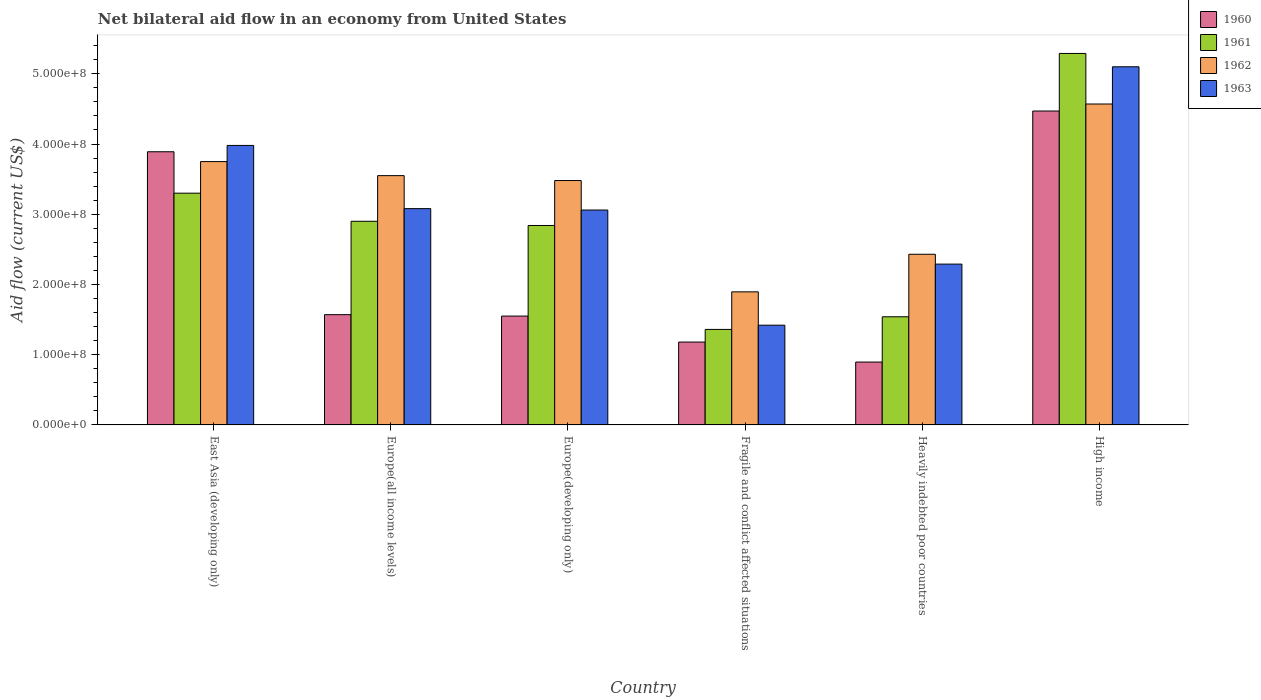How many different coloured bars are there?
Ensure brevity in your answer.  4. Are the number of bars per tick equal to the number of legend labels?
Offer a terse response. Yes. How many bars are there on the 6th tick from the left?
Make the answer very short. 4. What is the label of the 4th group of bars from the left?
Your answer should be very brief. Fragile and conflict affected situations. What is the net bilateral aid flow in 1961 in East Asia (developing only)?
Your answer should be compact. 3.30e+08. Across all countries, what is the maximum net bilateral aid flow in 1963?
Make the answer very short. 5.10e+08. Across all countries, what is the minimum net bilateral aid flow in 1960?
Your answer should be compact. 8.95e+07. In which country was the net bilateral aid flow in 1960 minimum?
Offer a terse response. Heavily indebted poor countries. What is the total net bilateral aid flow in 1962 in the graph?
Give a very brief answer. 1.97e+09. What is the difference between the net bilateral aid flow in 1963 in Europe(developing only) and that in High income?
Offer a very short reply. -2.04e+08. What is the difference between the net bilateral aid flow in 1962 in High income and the net bilateral aid flow in 1963 in Europe(developing only)?
Give a very brief answer. 1.51e+08. What is the average net bilateral aid flow in 1962 per country?
Offer a terse response. 3.28e+08. What is the difference between the net bilateral aid flow of/in 1963 and net bilateral aid flow of/in 1961 in High income?
Your response must be concise. -1.90e+07. What is the ratio of the net bilateral aid flow in 1963 in East Asia (developing only) to that in High income?
Keep it short and to the point. 0.78. Is the net bilateral aid flow in 1963 in Europe(developing only) less than that in Fragile and conflict affected situations?
Offer a terse response. No. What is the difference between the highest and the second highest net bilateral aid flow in 1962?
Give a very brief answer. 1.02e+08. What is the difference between the highest and the lowest net bilateral aid flow in 1963?
Offer a terse response. 3.68e+08. In how many countries, is the net bilateral aid flow in 1960 greater than the average net bilateral aid flow in 1960 taken over all countries?
Ensure brevity in your answer.  2. How many bars are there?
Ensure brevity in your answer.  24. What is the difference between two consecutive major ticks on the Y-axis?
Your answer should be compact. 1.00e+08. Does the graph contain any zero values?
Provide a succinct answer. No. Does the graph contain grids?
Keep it short and to the point. No. Where does the legend appear in the graph?
Your answer should be very brief. Top right. How many legend labels are there?
Give a very brief answer. 4. What is the title of the graph?
Provide a short and direct response. Net bilateral aid flow in an economy from United States. Does "1960" appear as one of the legend labels in the graph?
Keep it short and to the point. Yes. What is the label or title of the X-axis?
Your answer should be very brief. Country. What is the label or title of the Y-axis?
Ensure brevity in your answer.  Aid flow (current US$). What is the Aid flow (current US$) of 1960 in East Asia (developing only)?
Provide a succinct answer. 3.89e+08. What is the Aid flow (current US$) of 1961 in East Asia (developing only)?
Provide a succinct answer. 3.30e+08. What is the Aid flow (current US$) of 1962 in East Asia (developing only)?
Offer a very short reply. 3.75e+08. What is the Aid flow (current US$) of 1963 in East Asia (developing only)?
Ensure brevity in your answer.  3.98e+08. What is the Aid flow (current US$) of 1960 in Europe(all income levels)?
Offer a terse response. 1.57e+08. What is the Aid flow (current US$) of 1961 in Europe(all income levels)?
Make the answer very short. 2.90e+08. What is the Aid flow (current US$) of 1962 in Europe(all income levels)?
Offer a very short reply. 3.55e+08. What is the Aid flow (current US$) in 1963 in Europe(all income levels)?
Ensure brevity in your answer.  3.08e+08. What is the Aid flow (current US$) of 1960 in Europe(developing only)?
Give a very brief answer. 1.55e+08. What is the Aid flow (current US$) in 1961 in Europe(developing only)?
Ensure brevity in your answer.  2.84e+08. What is the Aid flow (current US$) in 1962 in Europe(developing only)?
Offer a terse response. 3.48e+08. What is the Aid flow (current US$) in 1963 in Europe(developing only)?
Provide a succinct answer. 3.06e+08. What is the Aid flow (current US$) in 1960 in Fragile and conflict affected situations?
Keep it short and to the point. 1.18e+08. What is the Aid flow (current US$) in 1961 in Fragile and conflict affected situations?
Ensure brevity in your answer.  1.36e+08. What is the Aid flow (current US$) in 1962 in Fragile and conflict affected situations?
Make the answer very short. 1.90e+08. What is the Aid flow (current US$) of 1963 in Fragile and conflict affected situations?
Give a very brief answer. 1.42e+08. What is the Aid flow (current US$) of 1960 in Heavily indebted poor countries?
Provide a succinct answer. 8.95e+07. What is the Aid flow (current US$) in 1961 in Heavily indebted poor countries?
Keep it short and to the point. 1.54e+08. What is the Aid flow (current US$) of 1962 in Heavily indebted poor countries?
Give a very brief answer. 2.43e+08. What is the Aid flow (current US$) of 1963 in Heavily indebted poor countries?
Keep it short and to the point. 2.29e+08. What is the Aid flow (current US$) in 1960 in High income?
Keep it short and to the point. 4.47e+08. What is the Aid flow (current US$) in 1961 in High income?
Make the answer very short. 5.29e+08. What is the Aid flow (current US$) of 1962 in High income?
Ensure brevity in your answer.  4.57e+08. What is the Aid flow (current US$) of 1963 in High income?
Your response must be concise. 5.10e+08. Across all countries, what is the maximum Aid flow (current US$) of 1960?
Your response must be concise. 4.47e+08. Across all countries, what is the maximum Aid flow (current US$) of 1961?
Make the answer very short. 5.29e+08. Across all countries, what is the maximum Aid flow (current US$) of 1962?
Ensure brevity in your answer.  4.57e+08. Across all countries, what is the maximum Aid flow (current US$) in 1963?
Ensure brevity in your answer.  5.10e+08. Across all countries, what is the minimum Aid flow (current US$) of 1960?
Your answer should be compact. 8.95e+07. Across all countries, what is the minimum Aid flow (current US$) in 1961?
Make the answer very short. 1.36e+08. Across all countries, what is the minimum Aid flow (current US$) in 1962?
Your response must be concise. 1.90e+08. Across all countries, what is the minimum Aid flow (current US$) in 1963?
Make the answer very short. 1.42e+08. What is the total Aid flow (current US$) of 1960 in the graph?
Your answer should be very brief. 1.36e+09. What is the total Aid flow (current US$) of 1961 in the graph?
Offer a very short reply. 1.72e+09. What is the total Aid flow (current US$) of 1962 in the graph?
Provide a succinct answer. 1.97e+09. What is the total Aid flow (current US$) in 1963 in the graph?
Your response must be concise. 1.89e+09. What is the difference between the Aid flow (current US$) of 1960 in East Asia (developing only) and that in Europe(all income levels)?
Offer a very short reply. 2.32e+08. What is the difference between the Aid flow (current US$) of 1961 in East Asia (developing only) and that in Europe(all income levels)?
Keep it short and to the point. 4.00e+07. What is the difference between the Aid flow (current US$) of 1962 in East Asia (developing only) and that in Europe(all income levels)?
Keep it short and to the point. 2.00e+07. What is the difference between the Aid flow (current US$) in 1963 in East Asia (developing only) and that in Europe(all income levels)?
Give a very brief answer. 9.00e+07. What is the difference between the Aid flow (current US$) in 1960 in East Asia (developing only) and that in Europe(developing only)?
Offer a very short reply. 2.34e+08. What is the difference between the Aid flow (current US$) in 1961 in East Asia (developing only) and that in Europe(developing only)?
Make the answer very short. 4.60e+07. What is the difference between the Aid flow (current US$) in 1962 in East Asia (developing only) and that in Europe(developing only)?
Make the answer very short. 2.70e+07. What is the difference between the Aid flow (current US$) of 1963 in East Asia (developing only) and that in Europe(developing only)?
Your response must be concise. 9.20e+07. What is the difference between the Aid flow (current US$) of 1960 in East Asia (developing only) and that in Fragile and conflict affected situations?
Your answer should be compact. 2.71e+08. What is the difference between the Aid flow (current US$) in 1961 in East Asia (developing only) and that in Fragile and conflict affected situations?
Give a very brief answer. 1.94e+08. What is the difference between the Aid flow (current US$) in 1962 in East Asia (developing only) and that in Fragile and conflict affected situations?
Ensure brevity in your answer.  1.86e+08. What is the difference between the Aid flow (current US$) of 1963 in East Asia (developing only) and that in Fragile and conflict affected situations?
Ensure brevity in your answer.  2.56e+08. What is the difference between the Aid flow (current US$) of 1960 in East Asia (developing only) and that in Heavily indebted poor countries?
Give a very brief answer. 2.99e+08. What is the difference between the Aid flow (current US$) of 1961 in East Asia (developing only) and that in Heavily indebted poor countries?
Make the answer very short. 1.76e+08. What is the difference between the Aid flow (current US$) in 1962 in East Asia (developing only) and that in Heavily indebted poor countries?
Your answer should be very brief. 1.32e+08. What is the difference between the Aid flow (current US$) of 1963 in East Asia (developing only) and that in Heavily indebted poor countries?
Provide a succinct answer. 1.69e+08. What is the difference between the Aid flow (current US$) of 1960 in East Asia (developing only) and that in High income?
Provide a succinct answer. -5.80e+07. What is the difference between the Aid flow (current US$) of 1961 in East Asia (developing only) and that in High income?
Provide a succinct answer. -1.99e+08. What is the difference between the Aid flow (current US$) of 1962 in East Asia (developing only) and that in High income?
Keep it short and to the point. -8.20e+07. What is the difference between the Aid flow (current US$) of 1963 in East Asia (developing only) and that in High income?
Keep it short and to the point. -1.12e+08. What is the difference between the Aid flow (current US$) in 1960 in Europe(all income levels) and that in Europe(developing only)?
Your answer should be compact. 2.00e+06. What is the difference between the Aid flow (current US$) in 1962 in Europe(all income levels) and that in Europe(developing only)?
Keep it short and to the point. 7.00e+06. What is the difference between the Aid flow (current US$) in 1960 in Europe(all income levels) and that in Fragile and conflict affected situations?
Ensure brevity in your answer.  3.90e+07. What is the difference between the Aid flow (current US$) in 1961 in Europe(all income levels) and that in Fragile and conflict affected situations?
Your answer should be compact. 1.54e+08. What is the difference between the Aid flow (current US$) of 1962 in Europe(all income levels) and that in Fragile and conflict affected situations?
Offer a terse response. 1.66e+08. What is the difference between the Aid flow (current US$) in 1963 in Europe(all income levels) and that in Fragile and conflict affected situations?
Provide a short and direct response. 1.66e+08. What is the difference between the Aid flow (current US$) of 1960 in Europe(all income levels) and that in Heavily indebted poor countries?
Keep it short and to the point. 6.75e+07. What is the difference between the Aid flow (current US$) in 1961 in Europe(all income levels) and that in Heavily indebted poor countries?
Keep it short and to the point. 1.36e+08. What is the difference between the Aid flow (current US$) of 1962 in Europe(all income levels) and that in Heavily indebted poor countries?
Make the answer very short. 1.12e+08. What is the difference between the Aid flow (current US$) in 1963 in Europe(all income levels) and that in Heavily indebted poor countries?
Your answer should be compact. 7.90e+07. What is the difference between the Aid flow (current US$) of 1960 in Europe(all income levels) and that in High income?
Provide a short and direct response. -2.90e+08. What is the difference between the Aid flow (current US$) in 1961 in Europe(all income levels) and that in High income?
Ensure brevity in your answer.  -2.39e+08. What is the difference between the Aid flow (current US$) in 1962 in Europe(all income levels) and that in High income?
Provide a succinct answer. -1.02e+08. What is the difference between the Aid flow (current US$) of 1963 in Europe(all income levels) and that in High income?
Your answer should be very brief. -2.02e+08. What is the difference between the Aid flow (current US$) in 1960 in Europe(developing only) and that in Fragile and conflict affected situations?
Keep it short and to the point. 3.70e+07. What is the difference between the Aid flow (current US$) of 1961 in Europe(developing only) and that in Fragile and conflict affected situations?
Provide a short and direct response. 1.48e+08. What is the difference between the Aid flow (current US$) of 1962 in Europe(developing only) and that in Fragile and conflict affected situations?
Make the answer very short. 1.58e+08. What is the difference between the Aid flow (current US$) of 1963 in Europe(developing only) and that in Fragile and conflict affected situations?
Your answer should be compact. 1.64e+08. What is the difference between the Aid flow (current US$) of 1960 in Europe(developing only) and that in Heavily indebted poor countries?
Provide a succinct answer. 6.55e+07. What is the difference between the Aid flow (current US$) in 1961 in Europe(developing only) and that in Heavily indebted poor countries?
Provide a short and direct response. 1.30e+08. What is the difference between the Aid flow (current US$) of 1962 in Europe(developing only) and that in Heavily indebted poor countries?
Offer a very short reply. 1.05e+08. What is the difference between the Aid flow (current US$) of 1963 in Europe(developing only) and that in Heavily indebted poor countries?
Provide a succinct answer. 7.70e+07. What is the difference between the Aid flow (current US$) of 1960 in Europe(developing only) and that in High income?
Provide a succinct answer. -2.92e+08. What is the difference between the Aid flow (current US$) in 1961 in Europe(developing only) and that in High income?
Offer a very short reply. -2.45e+08. What is the difference between the Aid flow (current US$) of 1962 in Europe(developing only) and that in High income?
Provide a short and direct response. -1.09e+08. What is the difference between the Aid flow (current US$) of 1963 in Europe(developing only) and that in High income?
Keep it short and to the point. -2.04e+08. What is the difference between the Aid flow (current US$) of 1960 in Fragile and conflict affected situations and that in Heavily indebted poor countries?
Give a very brief answer. 2.85e+07. What is the difference between the Aid flow (current US$) in 1961 in Fragile and conflict affected situations and that in Heavily indebted poor countries?
Your answer should be very brief. -1.80e+07. What is the difference between the Aid flow (current US$) in 1962 in Fragile and conflict affected situations and that in Heavily indebted poor countries?
Keep it short and to the point. -5.35e+07. What is the difference between the Aid flow (current US$) of 1963 in Fragile and conflict affected situations and that in Heavily indebted poor countries?
Provide a succinct answer. -8.70e+07. What is the difference between the Aid flow (current US$) in 1960 in Fragile and conflict affected situations and that in High income?
Keep it short and to the point. -3.29e+08. What is the difference between the Aid flow (current US$) in 1961 in Fragile and conflict affected situations and that in High income?
Ensure brevity in your answer.  -3.93e+08. What is the difference between the Aid flow (current US$) of 1962 in Fragile and conflict affected situations and that in High income?
Give a very brief answer. -2.68e+08. What is the difference between the Aid flow (current US$) in 1963 in Fragile and conflict affected situations and that in High income?
Your answer should be very brief. -3.68e+08. What is the difference between the Aid flow (current US$) of 1960 in Heavily indebted poor countries and that in High income?
Offer a terse response. -3.57e+08. What is the difference between the Aid flow (current US$) of 1961 in Heavily indebted poor countries and that in High income?
Offer a very short reply. -3.75e+08. What is the difference between the Aid flow (current US$) of 1962 in Heavily indebted poor countries and that in High income?
Offer a terse response. -2.14e+08. What is the difference between the Aid flow (current US$) in 1963 in Heavily indebted poor countries and that in High income?
Keep it short and to the point. -2.81e+08. What is the difference between the Aid flow (current US$) in 1960 in East Asia (developing only) and the Aid flow (current US$) in 1961 in Europe(all income levels)?
Offer a terse response. 9.90e+07. What is the difference between the Aid flow (current US$) of 1960 in East Asia (developing only) and the Aid flow (current US$) of 1962 in Europe(all income levels)?
Offer a terse response. 3.40e+07. What is the difference between the Aid flow (current US$) of 1960 in East Asia (developing only) and the Aid flow (current US$) of 1963 in Europe(all income levels)?
Your answer should be compact. 8.10e+07. What is the difference between the Aid flow (current US$) in 1961 in East Asia (developing only) and the Aid flow (current US$) in 1962 in Europe(all income levels)?
Ensure brevity in your answer.  -2.50e+07. What is the difference between the Aid flow (current US$) in 1961 in East Asia (developing only) and the Aid flow (current US$) in 1963 in Europe(all income levels)?
Ensure brevity in your answer.  2.20e+07. What is the difference between the Aid flow (current US$) of 1962 in East Asia (developing only) and the Aid flow (current US$) of 1963 in Europe(all income levels)?
Your answer should be compact. 6.70e+07. What is the difference between the Aid flow (current US$) in 1960 in East Asia (developing only) and the Aid flow (current US$) in 1961 in Europe(developing only)?
Keep it short and to the point. 1.05e+08. What is the difference between the Aid flow (current US$) of 1960 in East Asia (developing only) and the Aid flow (current US$) of 1962 in Europe(developing only)?
Your response must be concise. 4.10e+07. What is the difference between the Aid flow (current US$) in 1960 in East Asia (developing only) and the Aid flow (current US$) in 1963 in Europe(developing only)?
Your answer should be compact. 8.30e+07. What is the difference between the Aid flow (current US$) of 1961 in East Asia (developing only) and the Aid flow (current US$) of 1962 in Europe(developing only)?
Offer a very short reply. -1.80e+07. What is the difference between the Aid flow (current US$) of 1961 in East Asia (developing only) and the Aid flow (current US$) of 1963 in Europe(developing only)?
Make the answer very short. 2.40e+07. What is the difference between the Aid flow (current US$) in 1962 in East Asia (developing only) and the Aid flow (current US$) in 1963 in Europe(developing only)?
Provide a succinct answer. 6.90e+07. What is the difference between the Aid flow (current US$) in 1960 in East Asia (developing only) and the Aid flow (current US$) in 1961 in Fragile and conflict affected situations?
Make the answer very short. 2.53e+08. What is the difference between the Aid flow (current US$) in 1960 in East Asia (developing only) and the Aid flow (current US$) in 1962 in Fragile and conflict affected situations?
Make the answer very short. 2.00e+08. What is the difference between the Aid flow (current US$) in 1960 in East Asia (developing only) and the Aid flow (current US$) in 1963 in Fragile and conflict affected situations?
Ensure brevity in your answer.  2.47e+08. What is the difference between the Aid flow (current US$) in 1961 in East Asia (developing only) and the Aid flow (current US$) in 1962 in Fragile and conflict affected situations?
Your answer should be very brief. 1.40e+08. What is the difference between the Aid flow (current US$) of 1961 in East Asia (developing only) and the Aid flow (current US$) of 1963 in Fragile and conflict affected situations?
Offer a very short reply. 1.88e+08. What is the difference between the Aid flow (current US$) of 1962 in East Asia (developing only) and the Aid flow (current US$) of 1963 in Fragile and conflict affected situations?
Provide a succinct answer. 2.33e+08. What is the difference between the Aid flow (current US$) in 1960 in East Asia (developing only) and the Aid flow (current US$) in 1961 in Heavily indebted poor countries?
Your response must be concise. 2.35e+08. What is the difference between the Aid flow (current US$) of 1960 in East Asia (developing only) and the Aid flow (current US$) of 1962 in Heavily indebted poor countries?
Provide a short and direct response. 1.46e+08. What is the difference between the Aid flow (current US$) in 1960 in East Asia (developing only) and the Aid flow (current US$) in 1963 in Heavily indebted poor countries?
Your answer should be compact. 1.60e+08. What is the difference between the Aid flow (current US$) in 1961 in East Asia (developing only) and the Aid flow (current US$) in 1962 in Heavily indebted poor countries?
Your answer should be very brief. 8.70e+07. What is the difference between the Aid flow (current US$) in 1961 in East Asia (developing only) and the Aid flow (current US$) in 1963 in Heavily indebted poor countries?
Your response must be concise. 1.01e+08. What is the difference between the Aid flow (current US$) in 1962 in East Asia (developing only) and the Aid flow (current US$) in 1963 in Heavily indebted poor countries?
Offer a very short reply. 1.46e+08. What is the difference between the Aid flow (current US$) in 1960 in East Asia (developing only) and the Aid flow (current US$) in 1961 in High income?
Your answer should be compact. -1.40e+08. What is the difference between the Aid flow (current US$) in 1960 in East Asia (developing only) and the Aid flow (current US$) in 1962 in High income?
Ensure brevity in your answer.  -6.80e+07. What is the difference between the Aid flow (current US$) of 1960 in East Asia (developing only) and the Aid flow (current US$) of 1963 in High income?
Your response must be concise. -1.21e+08. What is the difference between the Aid flow (current US$) of 1961 in East Asia (developing only) and the Aid flow (current US$) of 1962 in High income?
Your answer should be very brief. -1.27e+08. What is the difference between the Aid flow (current US$) in 1961 in East Asia (developing only) and the Aid flow (current US$) in 1963 in High income?
Provide a short and direct response. -1.80e+08. What is the difference between the Aid flow (current US$) in 1962 in East Asia (developing only) and the Aid flow (current US$) in 1963 in High income?
Offer a very short reply. -1.35e+08. What is the difference between the Aid flow (current US$) in 1960 in Europe(all income levels) and the Aid flow (current US$) in 1961 in Europe(developing only)?
Provide a succinct answer. -1.27e+08. What is the difference between the Aid flow (current US$) in 1960 in Europe(all income levels) and the Aid flow (current US$) in 1962 in Europe(developing only)?
Provide a succinct answer. -1.91e+08. What is the difference between the Aid flow (current US$) in 1960 in Europe(all income levels) and the Aid flow (current US$) in 1963 in Europe(developing only)?
Offer a terse response. -1.49e+08. What is the difference between the Aid flow (current US$) of 1961 in Europe(all income levels) and the Aid flow (current US$) of 1962 in Europe(developing only)?
Ensure brevity in your answer.  -5.80e+07. What is the difference between the Aid flow (current US$) in 1961 in Europe(all income levels) and the Aid flow (current US$) in 1963 in Europe(developing only)?
Your response must be concise. -1.60e+07. What is the difference between the Aid flow (current US$) in 1962 in Europe(all income levels) and the Aid flow (current US$) in 1963 in Europe(developing only)?
Provide a short and direct response. 4.90e+07. What is the difference between the Aid flow (current US$) of 1960 in Europe(all income levels) and the Aid flow (current US$) of 1961 in Fragile and conflict affected situations?
Offer a very short reply. 2.10e+07. What is the difference between the Aid flow (current US$) of 1960 in Europe(all income levels) and the Aid flow (current US$) of 1962 in Fragile and conflict affected situations?
Your response must be concise. -3.25e+07. What is the difference between the Aid flow (current US$) of 1960 in Europe(all income levels) and the Aid flow (current US$) of 1963 in Fragile and conflict affected situations?
Offer a very short reply. 1.50e+07. What is the difference between the Aid flow (current US$) of 1961 in Europe(all income levels) and the Aid flow (current US$) of 1962 in Fragile and conflict affected situations?
Give a very brief answer. 1.00e+08. What is the difference between the Aid flow (current US$) in 1961 in Europe(all income levels) and the Aid flow (current US$) in 1963 in Fragile and conflict affected situations?
Provide a succinct answer. 1.48e+08. What is the difference between the Aid flow (current US$) of 1962 in Europe(all income levels) and the Aid flow (current US$) of 1963 in Fragile and conflict affected situations?
Ensure brevity in your answer.  2.13e+08. What is the difference between the Aid flow (current US$) of 1960 in Europe(all income levels) and the Aid flow (current US$) of 1961 in Heavily indebted poor countries?
Keep it short and to the point. 3.00e+06. What is the difference between the Aid flow (current US$) in 1960 in Europe(all income levels) and the Aid flow (current US$) in 1962 in Heavily indebted poor countries?
Your answer should be compact. -8.60e+07. What is the difference between the Aid flow (current US$) in 1960 in Europe(all income levels) and the Aid flow (current US$) in 1963 in Heavily indebted poor countries?
Make the answer very short. -7.20e+07. What is the difference between the Aid flow (current US$) of 1961 in Europe(all income levels) and the Aid flow (current US$) of 1962 in Heavily indebted poor countries?
Ensure brevity in your answer.  4.70e+07. What is the difference between the Aid flow (current US$) of 1961 in Europe(all income levels) and the Aid flow (current US$) of 1963 in Heavily indebted poor countries?
Your answer should be compact. 6.10e+07. What is the difference between the Aid flow (current US$) in 1962 in Europe(all income levels) and the Aid flow (current US$) in 1963 in Heavily indebted poor countries?
Offer a terse response. 1.26e+08. What is the difference between the Aid flow (current US$) in 1960 in Europe(all income levels) and the Aid flow (current US$) in 1961 in High income?
Offer a very short reply. -3.72e+08. What is the difference between the Aid flow (current US$) of 1960 in Europe(all income levels) and the Aid flow (current US$) of 1962 in High income?
Your answer should be compact. -3.00e+08. What is the difference between the Aid flow (current US$) in 1960 in Europe(all income levels) and the Aid flow (current US$) in 1963 in High income?
Your response must be concise. -3.53e+08. What is the difference between the Aid flow (current US$) of 1961 in Europe(all income levels) and the Aid flow (current US$) of 1962 in High income?
Provide a short and direct response. -1.67e+08. What is the difference between the Aid flow (current US$) in 1961 in Europe(all income levels) and the Aid flow (current US$) in 1963 in High income?
Provide a short and direct response. -2.20e+08. What is the difference between the Aid flow (current US$) in 1962 in Europe(all income levels) and the Aid flow (current US$) in 1963 in High income?
Your answer should be compact. -1.55e+08. What is the difference between the Aid flow (current US$) of 1960 in Europe(developing only) and the Aid flow (current US$) of 1961 in Fragile and conflict affected situations?
Make the answer very short. 1.90e+07. What is the difference between the Aid flow (current US$) of 1960 in Europe(developing only) and the Aid flow (current US$) of 1962 in Fragile and conflict affected situations?
Offer a very short reply. -3.45e+07. What is the difference between the Aid flow (current US$) in 1960 in Europe(developing only) and the Aid flow (current US$) in 1963 in Fragile and conflict affected situations?
Provide a succinct answer. 1.30e+07. What is the difference between the Aid flow (current US$) in 1961 in Europe(developing only) and the Aid flow (current US$) in 1962 in Fragile and conflict affected situations?
Keep it short and to the point. 9.45e+07. What is the difference between the Aid flow (current US$) in 1961 in Europe(developing only) and the Aid flow (current US$) in 1963 in Fragile and conflict affected situations?
Your response must be concise. 1.42e+08. What is the difference between the Aid flow (current US$) of 1962 in Europe(developing only) and the Aid flow (current US$) of 1963 in Fragile and conflict affected situations?
Your response must be concise. 2.06e+08. What is the difference between the Aid flow (current US$) in 1960 in Europe(developing only) and the Aid flow (current US$) in 1962 in Heavily indebted poor countries?
Your response must be concise. -8.80e+07. What is the difference between the Aid flow (current US$) of 1960 in Europe(developing only) and the Aid flow (current US$) of 1963 in Heavily indebted poor countries?
Provide a succinct answer. -7.40e+07. What is the difference between the Aid flow (current US$) in 1961 in Europe(developing only) and the Aid flow (current US$) in 1962 in Heavily indebted poor countries?
Ensure brevity in your answer.  4.10e+07. What is the difference between the Aid flow (current US$) in 1961 in Europe(developing only) and the Aid flow (current US$) in 1963 in Heavily indebted poor countries?
Provide a succinct answer. 5.50e+07. What is the difference between the Aid flow (current US$) of 1962 in Europe(developing only) and the Aid flow (current US$) of 1963 in Heavily indebted poor countries?
Your answer should be very brief. 1.19e+08. What is the difference between the Aid flow (current US$) in 1960 in Europe(developing only) and the Aid flow (current US$) in 1961 in High income?
Provide a succinct answer. -3.74e+08. What is the difference between the Aid flow (current US$) in 1960 in Europe(developing only) and the Aid flow (current US$) in 1962 in High income?
Ensure brevity in your answer.  -3.02e+08. What is the difference between the Aid flow (current US$) of 1960 in Europe(developing only) and the Aid flow (current US$) of 1963 in High income?
Offer a terse response. -3.55e+08. What is the difference between the Aid flow (current US$) of 1961 in Europe(developing only) and the Aid flow (current US$) of 1962 in High income?
Provide a succinct answer. -1.73e+08. What is the difference between the Aid flow (current US$) of 1961 in Europe(developing only) and the Aid flow (current US$) of 1963 in High income?
Provide a short and direct response. -2.26e+08. What is the difference between the Aid flow (current US$) in 1962 in Europe(developing only) and the Aid flow (current US$) in 1963 in High income?
Your answer should be compact. -1.62e+08. What is the difference between the Aid flow (current US$) in 1960 in Fragile and conflict affected situations and the Aid flow (current US$) in 1961 in Heavily indebted poor countries?
Give a very brief answer. -3.60e+07. What is the difference between the Aid flow (current US$) of 1960 in Fragile and conflict affected situations and the Aid flow (current US$) of 1962 in Heavily indebted poor countries?
Your response must be concise. -1.25e+08. What is the difference between the Aid flow (current US$) of 1960 in Fragile and conflict affected situations and the Aid flow (current US$) of 1963 in Heavily indebted poor countries?
Give a very brief answer. -1.11e+08. What is the difference between the Aid flow (current US$) in 1961 in Fragile and conflict affected situations and the Aid flow (current US$) in 1962 in Heavily indebted poor countries?
Provide a short and direct response. -1.07e+08. What is the difference between the Aid flow (current US$) in 1961 in Fragile and conflict affected situations and the Aid flow (current US$) in 1963 in Heavily indebted poor countries?
Keep it short and to the point. -9.30e+07. What is the difference between the Aid flow (current US$) of 1962 in Fragile and conflict affected situations and the Aid flow (current US$) of 1963 in Heavily indebted poor countries?
Your answer should be compact. -3.95e+07. What is the difference between the Aid flow (current US$) in 1960 in Fragile and conflict affected situations and the Aid flow (current US$) in 1961 in High income?
Provide a succinct answer. -4.11e+08. What is the difference between the Aid flow (current US$) of 1960 in Fragile and conflict affected situations and the Aid flow (current US$) of 1962 in High income?
Ensure brevity in your answer.  -3.39e+08. What is the difference between the Aid flow (current US$) of 1960 in Fragile and conflict affected situations and the Aid flow (current US$) of 1963 in High income?
Your answer should be very brief. -3.92e+08. What is the difference between the Aid flow (current US$) in 1961 in Fragile and conflict affected situations and the Aid flow (current US$) in 1962 in High income?
Ensure brevity in your answer.  -3.21e+08. What is the difference between the Aid flow (current US$) of 1961 in Fragile and conflict affected situations and the Aid flow (current US$) of 1963 in High income?
Give a very brief answer. -3.74e+08. What is the difference between the Aid flow (current US$) in 1962 in Fragile and conflict affected situations and the Aid flow (current US$) in 1963 in High income?
Keep it short and to the point. -3.20e+08. What is the difference between the Aid flow (current US$) of 1960 in Heavily indebted poor countries and the Aid flow (current US$) of 1961 in High income?
Provide a succinct answer. -4.39e+08. What is the difference between the Aid flow (current US$) of 1960 in Heavily indebted poor countries and the Aid flow (current US$) of 1962 in High income?
Your response must be concise. -3.67e+08. What is the difference between the Aid flow (current US$) of 1960 in Heavily indebted poor countries and the Aid flow (current US$) of 1963 in High income?
Keep it short and to the point. -4.20e+08. What is the difference between the Aid flow (current US$) of 1961 in Heavily indebted poor countries and the Aid flow (current US$) of 1962 in High income?
Provide a succinct answer. -3.03e+08. What is the difference between the Aid flow (current US$) of 1961 in Heavily indebted poor countries and the Aid flow (current US$) of 1963 in High income?
Your answer should be compact. -3.56e+08. What is the difference between the Aid flow (current US$) in 1962 in Heavily indebted poor countries and the Aid flow (current US$) in 1963 in High income?
Your answer should be compact. -2.67e+08. What is the average Aid flow (current US$) of 1960 per country?
Provide a succinct answer. 2.26e+08. What is the average Aid flow (current US$) of 1961 per country?
Give a very brief answer. 2.87e+08. What is the average Aid flow (current US$) in 1962 per country?
Provide a short and direct response. 3.28e+08. What is the average Aid flow (current US$) of 1963 per country?
Offer a very short reply. 3.16e+08. What is the difference between the Aid flow (current US$) of 1960 and Aid flow (current US$) of 1961 in East Asia (developing only)?
Keep it short and to the point. 5.90e+07. What is the difference between the Aid flow (current US$) in 1960 and Aid flow (current US$) in 1962 in East Asia (developing only)?
Give a very brief answer. 1.40e+07. What is the difference between the Aid flow (current US$) in 1960 and Aid flow (current US$) in 1963 in East Asia (developing only)?
Your response must be concise. -9.00e+06. What is the difference between the Aid flow (current US$) of 1961 and Aid flow (current US$) of 1962 in East Asia (developing only)?
Provide a succinct answer. -4.50e+07. What is the difference between the Aid flow (current US$) of 1961 and Aid flow (current US$) of 1963 in East Asia (developing only)?
Offer a terse response. -6.80e+07. What is the difference between the Aid flow (current US$) in 1962 and Aid flow (current US$) in 1963 in East Asia (developing only)?
Offer a very short reply. -2.30e+07. What is the difference between the Aid flow (current US$) in 1960 and Aid flow (current US$) in 1961 in Europe(all income levels)?
Your answer should be compact. -1.33e+08. What is the difference between the Aid flow (current US$) in 1960 and Aid flow (current US$) in 1962 in Europe(all income levels)?
Give a very brief answer. -1.98e+08. What is the difference between the Aid flow (current US$) in 1960 and Aid flow (current US$) in 1963 in Europe(all income levels)?
Offer a very short reply. -1.51e+08. What is the difference between the Aid flow (current US$) of 1961 and Aid flow (current US$) of 1962 in Europe(all income levels)?
Keep it short and to the point. -6.50e+07. What is the difference between the Aid flow (current US$) of 1961 and Aid flow (current US$) of 1963 in Europe(all income levels)?
Give a very brief answer. -1.80e+07. What is the difference between the Aid flow (current US$) in 1962 and Aid flow (current US$) in 1963 in Europe(all income levels)?
Provide a succinct answer. 4.70e+07. What is the difference between the Aid flow (current US$) in 1960 and Aid flow (current US$) in 1961 in Europe(developing only)?
Provide a succinct answer. -1.29e+08. What is the difference between the Aid flow (current US$) in 1960 and Aid flow (current US$) in 1962 in Europe(developing only)?
Keep it short and to the point. -1.93e+08. What is the difference between the Aid flow (current US$) in 1960 and Aid flow (current US$) in 1963 in Europe(developing only)?
Make the answer very short. -1.51e+08. What is the difference between the Aid flow (current US$) of 1961 and Aid flow (current US$) of 1962 in Europe(developing only)?
Give a very brief answer. -6.40e+07. What is the difference between the Aid flow (current US$) in 1961 and Aid flow (current US$) in 1963 in Europe(developing only)?
Ensure brevity in your answer.  -2.20e+07. What is the difference between the Aid flow (current US$) of 1962 and Aid flow (current US$) of 1963 in Europe(developing only)?
Offer a very short reply. 4.20e+07. What is the difference between the Aid flow (current US$) of 1960 and Aid flow (current US$) of 1961 in Fragile and conflict affected situations?
Keep it short and to the point. -1.80e+07. What is the difference between the Aid flow (current US$) in 1960 and Aid flow (current US$) in 1962 in Fragile and conflict affected situations?
Ensure brevity in your answer.  -7.15e+07. What is the difference between the Aid flow (current US$) of 1960 and Aid flow (current US$) of 1963 in Fragile and conflict affected situations?
Give a very brief answer. -2.40e+07. What is the difference between the Aid flow (current US$) of 1961 and Aid flow (current US$) of 1962 in Fragile and conflict affected situations?
Ensure brevity in your answer.  -5.35e+07. What is the difference between the Aid flow (current US$) of 1961 and Aid flow (current US$) of 1963 in Fragile and conflict affected situations?
Your response must be concise. -6.00e+06. What is the difference between the Aid flow (current US$) of 1962 and Aid flow (current US$) of 1963 in Fragile and conflict affected situations?
Your answer should be compact. 4.75e+07. What is the difference between the Aid flow (current US$) of 1960 and Aid flow (current US$) of 1961 in Heavily indebted poor countries?
Offer a terse response. -6.45e+07. What is the difference between the Aid flow (current US$) in 1960 and Aid flow (current US$) in 1962 in Heavily indebted poor countries?
Keep it short and to the point. -1.53e+08. What is the difference between the Aid flow (current US$) in 1960 and Aid flow (current US$) in 1963 in Heavily indebted poor countries?
Your answer should be very brief. -1.39e+08. What is the difference between the Aid flow (current US$) of 1961 and Aid flow (current US$) of 1962 in Heavily indebted poor countries?
Keep it short and to the point. -8.90e+07. What is the difference between the Aid flow (current US$) in 1961 and Aid flow (current US$) in 1963 in Heavily indebted poor countries?
Give a very brief answer. -7.50e+07. What is the difference between the Aid flow (current US$) of 1962 and Aid flow (current US$) of 1963 in Heavily indebted poor countries?
Provide a short and direct response. 1.40e+07. What is the difference between the Aid flow (current US$) of 1960 and Aid flow (current US$) of 1961 in High income?
Offer a very short reply. -8.20e+07. What is the difference between the Aid flow (current US$) of 1960 and Aid flow (current US$) of 1962 in High income?
Offer a very short reply. -1.00e+07. What is the difference between the Aid flow (current US$) in 1960 and Aid flow (current US$) in 1963 in High income?
Offer a very short reply. -6.30e+07. What is the difference between the Aid flow (current US$) in 1961 and Aid flow (current US$) in 1962 in High income?
Your answer should be very brief. 7.20e+07. What is the difference between the Aid flow (current US$) in 1961 and Aid flow (current US$) in 1963 in High income?
Offer a terse response. 1.90e+07. What is the difference between the Aid flow (current US$) in 1962 and Aid flow (current US$) in 1963 in High income?
Give a very brief answer. -5.30e+07. What is the ratio of the Aid flow (current US$) in 1960 in East Asia (developing only) to that in Europe(all income levels)?
Provide a succinct answer. 2.48. What is the ratio of the Aid flow (current US$) in 1961 in East Asia (developing only) to that in Europe(all income levels)?
Your response must be concise. 1.14. What is the ratio of the Aid flow (current US$) in 1962 in East Asia (developing only) to that in Europe(all income levels)?
Offer a very short reply. 1.06. What is the ratio of the Aid flow (current US$) of 1963 in East Asia (developing only) to that in Europe(all income levels)?
Provide a short and direct response. 1.29. What is the ratio of the Aid flow (current US$) of 1960 in East Asia (developing only) to that in Europe(developing only)?
Your response must be concise. 2.51. What is the ratio of the Aid flow (current US$) of 1961 in East Asia (developing only) to that in Europe(developing only)?
Give a very brief answer. 1.16. What is the ratio of the Aid flow (current US$) of 1962 in East Asia (developing only) to that in Europe(developing only)?
Offer a terse response. 1.08. What is the ratio of the Aid flow (current US$) in 1963 in East Asia (developing only) to that in Europe(developing only)?
Give a very brief answer. 1.3. What is the ratio of the Aid flow (current US$) of 1960 in East Asia (developing only) to that in Fragile and conflict affected situations?
Ensure brevity in your answer.  3.3. What is the ratio of the Aid flow (current US$) in 1961 in East Asia (developing only) to that in Fragile and conflict affected situations?
Keep it short and to the point. 2.43. What is the ratio of the Aid flow (current US$) of 1962 in East Asia (developing only) to that in Fragile and conflict affected situations?
Ensure brevity in your answer.  1.98. What is the ratio of the Aid flow (current US$) of 1963 in East Asia (developing only) to that in Fragile and conflict affected situations?
Offer a terse response. 2.8. What is the ratio of the Aid flow (current US$) in 1960 in East Asia (developing only) to that in Heavily indebted poor countries?
Give a very brief answer. 4.35. What is the ratio of the Aid flow (current US$) of 1961 in East Asia (developing only) to that in Heavily indebted poor countries?
Your answer should be compact. 2.14. What is the ratio of the Aid flow (current US$) of 1962 in East Asia (developing only) to that in Heavily indebted poor countries?
Keep it short and to the point. 1.54. What is the ratio of the Aid flow (current US$) of 1963 in East Asia (developing only) to that in Heavily indebted poor countries?
Offer a terse response. 1.74. What is the ratio of the Aid flow (current US$) in 1960 in East Asia (developing only) to that in High income?
Ensure brevity in your answer.  0.87. What is the ratio of the Aid flow (current US$) in 1961 in East Asia (developing only) to that in High income?
Ensure brevity in your answer.  0.62. What is the ratio of the Aid flow (current US$) in 1962 in East Asia (developing only) to that in High income?
Your response must be concise. 0.82. What is the ratio of the Aid flow (current US$) in 1963 in East Asia (developing only) to that in High income?
Offer a terse response. 0.78. What is the ratio of the Aid flow (current US$) of 1960 in Europe(all income levels) to that in Europe(developing only)?
Your answer should be very brief. 1.01. What is the ratio of the Aid flow (current US$) in 1961 in Europe(all income levels) to that in Europe(developing only)?
Make the answer very short. 1.02. What is the ratio of the Aid flow (current US$) in 1962 in Europe(all income levels) to that in Europe(developing only)?
Your answer should be compact. 1.02. What is the ratio of the Aid flow (current US$) in 1960 in Europe(all income levels) to that in Fragile and conflict affected situations?
Provide a short and direct response. 1.33. What is the ratio of the Aid flow (current US$) in 1961 in Europe(all income levels) to that in Fragile and conflict affected situations?
Provide a succinct answer. 2.13. What is the ratio of the Aid flow (current US$) of 1962 in Europe(all income levels) to that in Fragile and conflict affected situations?
Provide a succinct answer. 1.87. What is the ratio of the Aid flow (current US$) in 1963 in Europe(all income levels) to that in Fragile and conflict affected situations?
Offer a very short reply. 2.17. What is the ratio of the Aid flow (current US$) in 1960 in Europe(all income levels) to that in Heavily indebted poor countries?
Your response must be concise. 1.75. What is the ratio of the Aid flow (current US$) of 1961 in Europe(all income levels) to that in Heavily indebted poor countries?
Offer a terse response. 1.88. What is the ratio of the Aid flow (current US$) in 1962 in Europe(all income levels) to that in Heavily indebted poor countries?
Provide a succinct answer. 1.46. What is the ratio of the Aid flow (current US$) in 1963 in Europe(all income levels) to that in Heavily indebted poor countries?
Ensure brevity in your answer.  1.34. What is the ratio of the Aid flow (current US$) in 1960 in Europe(all income levels) to that in High income?
Your answer should be compact. 0.35. What is the ratio of the Aid flow (current US$) of 1961 in Europe(all income levels) to that in High income?
Give a very brief answer. 0.55. What is the ratio of the Aid flow (current US$) of 1962 in Europe(all income levels) to that in High income?
Keep it short and to the point. 0.78. What is the ratio of the Aid flow (current US$) of 1963 in Europe(all income levels) to that in High income?
Make the answer very short. 0.6. What is the ratio of the Aid flow (current US$) of 1960 in Europe(developing only) to that in Fragile and conflict affected situations?
Your answer should be compact. 1.31. What is the ratio of the Aid flow (current US$) of 1961 in Europe(developing only) to that in Fragile and conflict affected situations?
Your response must be concise. 2.09. What is the ratio of the Aid flow (current US$) of 1962 in Europe(developing only) to that in Fragile and conflict affected situations?
Your answer should be very brief. 1.84. What is the ratio of the Aid flow (current US$) in 1963 in Europe(developing only) to that in Fragile and conflict affected situations?
Your response must be concise. 2.15. What is the ratio of the Aid flow (current US$) in 1960 in Europe(developing only) to that in Heavily indebted poor countries?
Keep it short and to the point. 1.73. What is the ratio of the Aid flow (current US$) of 1961 in Europe(developing only) to that in Heavily indebted poor countries?
Ensure brevity in your answer.  1.84. What is the ratio of the Aid flow (current US$) of 1962 in Europe(developing only) to that in Heavily indebted poor countries?
Give a very brief answer. 1.43. What is the ratio of the Aid flow (current US$) in 1963 in Europe(developing only) to that in Heavily indebted poor countries?
Give a very brief answer. 1.34. What is the ratio of the Aid flow (current US$) in 1960 in Europe(developing only) to that in High income?
Your response must be concise. 0.35. What is the ratio of the Aid flow (current US$) in 1961 in Europe(developing only) to that in High income?
Offer a terse response. 0.54. What is the ratio of the Aid flow (current US$) in 1962 in Europe(developing only) to that in High income?
Make the answer very short. 0.76. What is the ratio of the Aid flow (current US$) of 1960 in Fragile and conflict affected situations to that in Heavily indebted poor countries?
Provide a short and direct response. 1.32. What is the ratio of the Aid flow (current US$) in 1961 in Fragile and conflict affected situations to that in Heavily indebted poor countries?
Your answer should be very brief. 0.88. What is the ratio of the Aid flow (current US$) in 1962 in Fragile and conflict affected situations to that in Heavily indebted poor countries?
Give a very brief answer. 0.78. What is the ratio of the Aid flow (current US$) in 1963 in Fragile and conflict affected situations to that in Heavily indebted poor countries?
Offer a very short reply. 0.62. What is the ratio of the Aid flow (current US$) in 1960 in Fragile and conflict affected situations to that in High income?
Offer a very short reply. 0.26. What is the ratio of the Aid flow (current US$) in 1961 in Fragile and conflict affected situations to that in High income?
Make the answer very short. 0.26. What is the ratio of the Aid flow (current US$) in 1962 in Fragile and conflict affected situations to that in High income?
Provide a succinct answer. 0.41. What is the ratio of the Aid flow (current US$) in 1963 in Fragile and conflict affected situations to that in High income?
Keep it short and to the point. 0.28. What is the ratio of the Aid flow (current US$) in 1960 in Heavily indebted poor countries to that in High income?
Offer a very short reply. 0.2. What is the ratio of the Aid flow (current US$) in 1961 in Heavily indebted poor countries to that in High income?
Offer a terse response. 0.29. What is the ratio of the Aid flow (current US$) of 1962 in Heavily indebted poor countries to that in High income?
Keep it short and to the point. 0.53. What is the ratio of the Aid flow (current US$) in 1963 in Heavily indebted poor countries to that in High income?
Make the answer very short. 0.45. What is the difference between the highest and the second highest Aid flow (current US$) in 1960?
Offer a very short reply. 5.80e+07. What is the difference between the highest and the second highest Aid flow (current US$) in 1961?
Your answer should be very brief. 1.99e+08. What is the difference between the highest and the second highest Aid flow (current US$) in 1962?
Your answer should be very brief. 8.20e+07. What is the difference between the highest and the second highest Aid flow (current US$) of 1963?
Offer a very short reply. 1.12e+08. What is the difference between the highest and the lowest Aid flow (current US$) in 1960?
Provide a succinct answer. 3.57e+08. What is the difference between the highest and the lowest Aid flow (current US$) of 1961?
Keep it short and to the point. 3.93e+08. What is the difference between the highest and the lowest Aid flow (current US$) in 1962?
Your answer should be very brief. 2.68e+08. What is the difference between the highest and the lowest Aid flow (current US$) of 1963?
Your response must be concise. 3.68e+08. 